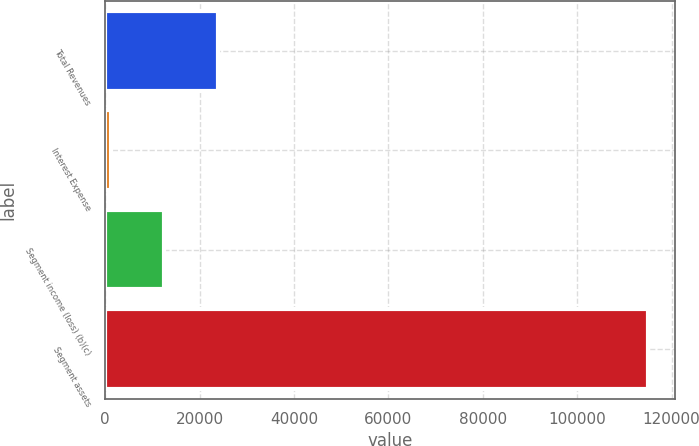Convert chart to OTSL. <chart><loc_0><loc_0><loc_500><loc_500><bar_chart><fcel>Total Revenues<fcel>Interest Expense<fcel>Segment income (loss) (b)(c)<fcel>Segment assets<nl><fcel>23907.4<fcel>1136<fcel>12521.7<fcel>114993<nl></chart> 